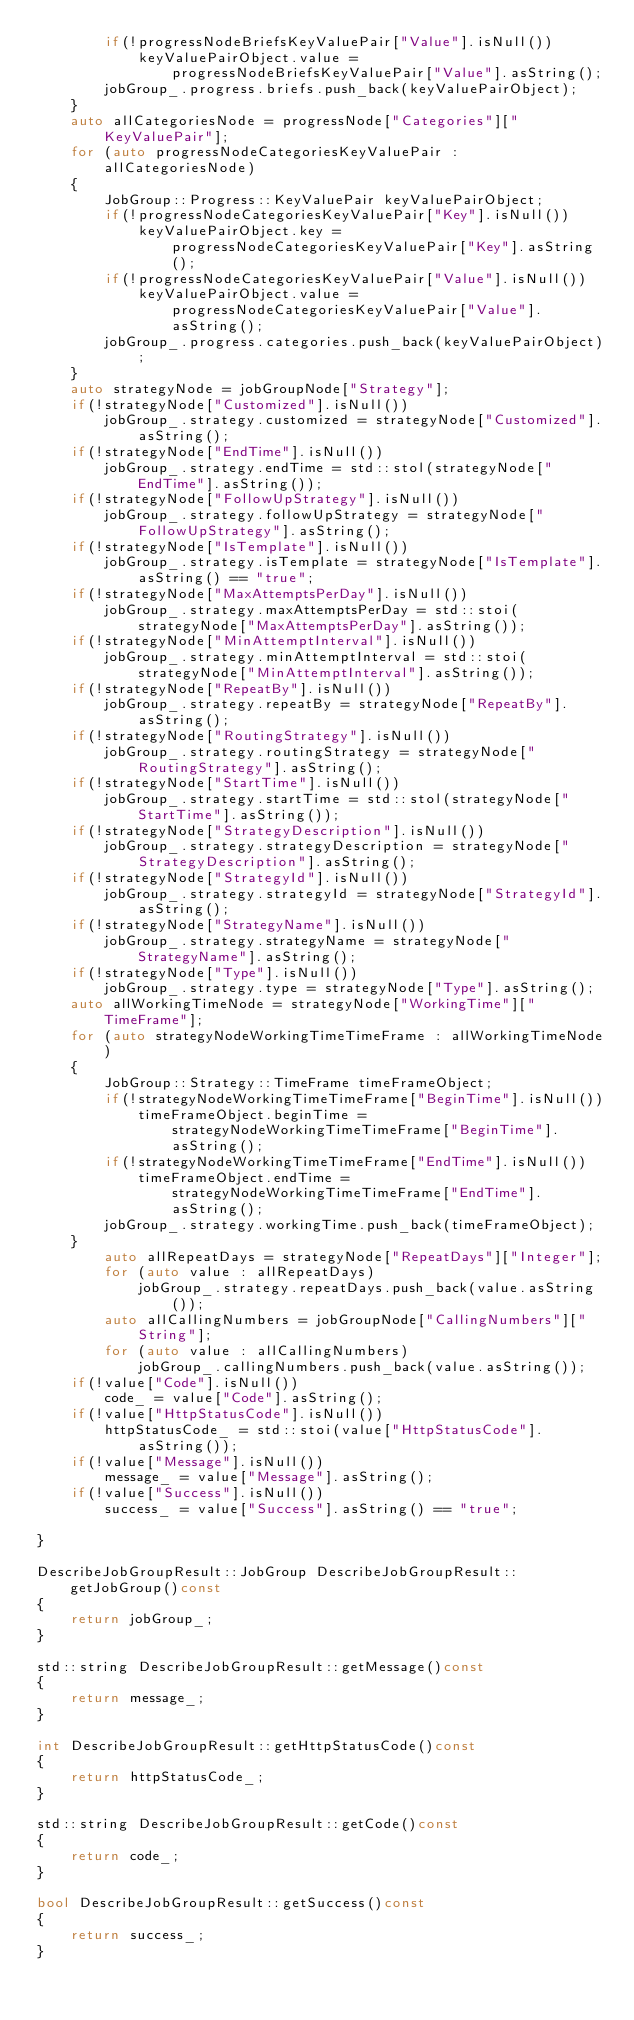<code> <loc_0><loc_0><loc_500><loc_500><_C++_>		if(!progressNodeBriefsKeyValuePair["Value"].isNull())
			keyValuePairObject.value = progressNodeBriefsKeyValuePair["Value"].asString();
		jobGroup_.progress.briefs.push_back(keyValuePairObject);
	}
	auto allCategoriesNode = progressNode["Categories"]["KeyValuePair"];
	for (auto progressNodeCategoriesKeyValuePair : allCategoriesNode)
	{
		JobGroup::Progress::KeyValuePair keyValuePairObject;
		if(!progressNodeCategoriesKeyValuePair["Key"].isNull())
			keyValuePairObject.key = progressNodeCategoriesKeyValuePair["Key"].asString();
		if(!progressNodeCategoriesKeyValuePair["Value"].isNull())
			keyValuePairObject.value = progressNodeCategoriesKeyValuePair["Value"].asString();
		jobGroup_.progress.categories.push_back(keyValuePairObject);
	}
	auto strategyNode = jobGroupNode["Strategy"];
	if(!strategyNode["Customized"].isNull())
		jobGroup_.strategy.customized = strategyNode["Customized"].asString();
	if(!strategyNode["EndTime"].isNull())
		jobGroup_.strategy.endTime = std::stol(strategyNode["EndTime"].asString());
	if(!strategyNode["FollowUpStrategy"].isNull())
		jobGroup_.strategy.followUpStrategy = strategyNode["FollowUpStrategy"].asString();
	if(!strategyNode["IsTemplate"].isNull())
		jobGroup_.strategy.isTemplate = strategyNode["IsTemplate"].asString() == "true";
	if(!strategyNode["MaxAttemptsPerDay"].isNull())
		jobGroup_.strategy.maxAttemptsPerDay = std::stoi(strategyNode["MaxAttemptsPerDay"].asString());
	if(!strategyNode["MinAttemptInterval"].isNull())
		jobGroup_.strategy.minAttemptInterval = std::stoi(strategyNode["MinAttemptInterval"].asString());
	if(!strategyNode["RepeatBy"].isNull())
		jobGroup_.strategy.repeatBy = strategyNode["RepeatBy"].asString();
	if(!strategyNode["RoutingStrategy"].isNull())
		jobGroup_.strategy.routingStrategy = strategyNode["RoutingStrategy"].asString();
	if(!strategyNode["StartTime"].isNull())
		jobGroup_.strategy.startTime = std::stol(strategyNode["StartTime"].asString());
	if(!strategyNode["StrategyDescription"].isNull())
		jobGroup_.strategy.strategyDescription = strategyNode["StrategyDescription"].asString();
	if(!strategyNode["StrategyId"].isNull())
		jobGroup_.strategy.strategyId = strategyNode["StrategyId"].asString();
	if(!strategyNode["StrategyName"].isNull())
		jobGroup_.strategy.strategyName = strategyNode["StrategyName"].asString();
	if(!strategyNode["Type"].isNull())
		jobGroup_.strategy.type = strategyNode["Type"].asString();
	auto allWorkingTimeNode = strategyNode["WorkingTime"]["TimeFrame"];
	for (auto strategyNodeWorkingTimeTimeFrame : allWorkingTimeNode)
	{
		JobGroup::Strategy::TimeFrame timeFrameObject;
		if(!strategyNodeWorkingTimeTimeFrame["BeginTime"].isNull())
			timeFrameObject.beginTime = strategyNodeWorkingTimeTimeFrame["BeginTime"].asString();
		if(!strategyNodeWorkingTimeTimeFrame["EndTime"].isNull())
			timeFrameObject.endTime = strategyNodeWorkingTimeTimeFrame["EndTime"].asString();
		jobGroup_.strategy.workingTime.push_back(timeFrameObject);
	}
		auto allRepeatDays = strategyNode["RepeatDays"]["Integer"];
		for (auto value : allRepeatDays)
			jobGroup_.strategy.repeatDays.push_back(value.asString());
		auto allCallingNumbers = jobGroupNode["CallingNumbers"]["String"];
		for (auto value : allCallingNumbers)
			jobGroup_.callingNumbers.push_back(value.asString());
	if(!value["Code"].isNull())
		code_ = value["Code"].asString();
	if(!value["HttpStatusCode"].isNull())
		httpStatusCode_ = std::stoi(value["HttpStatusCode"].asString());
	if(!value["Message"].isNull())
		message_ = value["Message"].asString();
	if(!value["Success"].isNull())
		success_ = value["Success"].asString() == "true";

}

DescribeJobGroupResult::JobGroup DescribeJobGroupResult::getJobGroup()const
{
	return jobGroup_;
}

std::string DescribeJobGroupResult::getMessage()const
{
	return message_;
}

int DescribeJobGroupResult::getHttpStatusCode()const
{
	return httpStatusCode_;
}

std::string DescribeJobGroupResult::getCode()const
{
	return code_;
}

bool DescribeJobGroupResult::getSuccess()const
{
	return success_;
}

</code> 